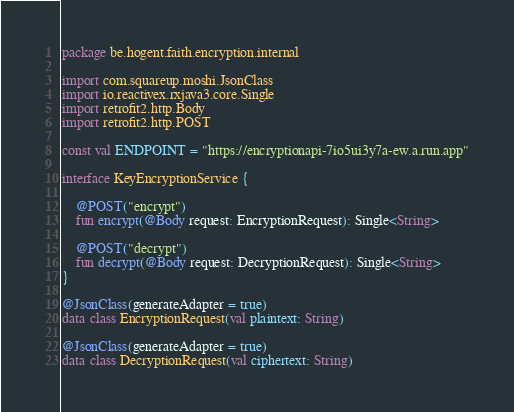<code> <loc_0><loc_0><loc_500><loc_500><_Kotlin_>package be.hogent.faith.encryption.internal

import com.squareup.moshi.JsonClass
import io.reactivex.rxjava3.core.Single
import retrofit2.http.Body
import retrofit2.http.POST

const val ENDPOINT = "https://encryptionapi-7io5ui3y7a-ew.a.run.app"

interface KeyEncryptionService {

    @POST("encrypt")
    fun encrypt(@Body request: EncryptionRequest): Single<String>

    @POST("decrypt")
    fun decrypt(@Body request: DecryptionRequest): Single<String>
}

@JsonClass(generateAdapter = true)
data class EncryptionRequest(val plaintext: String)

@JsonClass(generateAdapter = true)
data class DecryptionRequest(val ciphertext: String)
</code> 